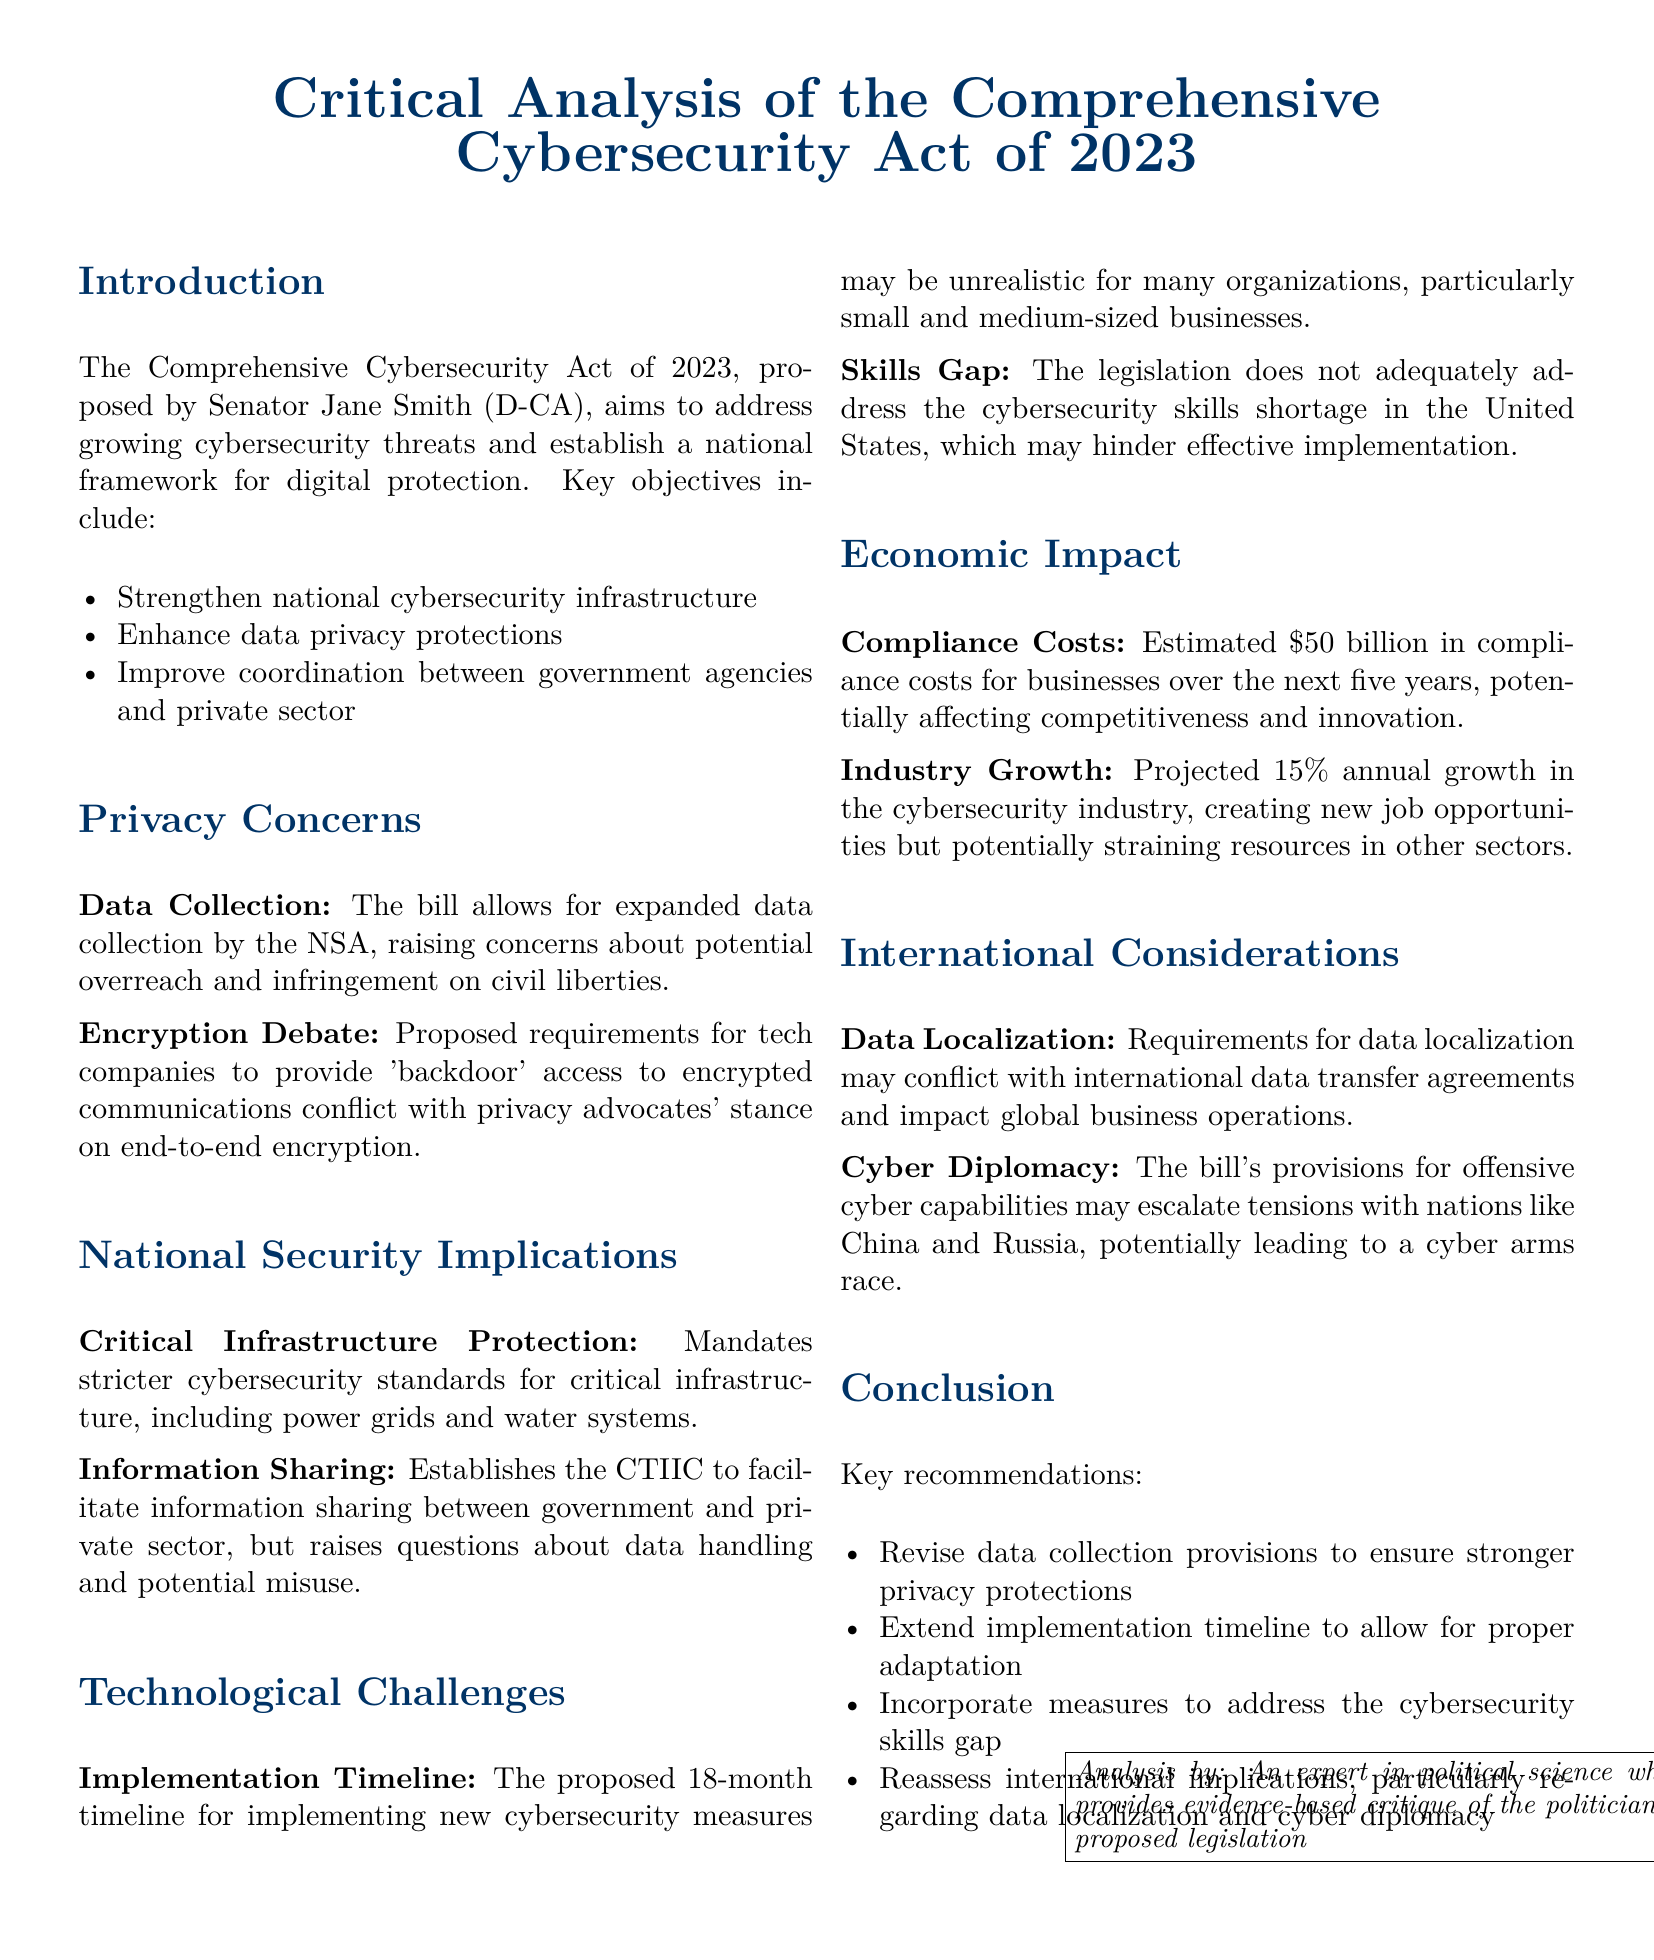What is the title of the proposed legislation? The title is presented at the beginning of the document, highlighting its focus on cybersecurity.
Answer: Comprehensive Cybersecurity Act of 2023 Who proposed the Comprehensive Cybersecurity Act? The document identifies the sponsor of the legislation.
Answer: Senator Jane Smith (D-CA) What is the estimated compliance cost for businesses over five years? This figure is provided in the Economic Impact section of the document.
Answer: $50 billion How long is the proposed implementation timeline for new cybersecurity measures? The document specifies the timeline mentioned in the Technological Challenges section.
Answer: 18 months What percentage is projected for annual growth in the cybersecurity industry? The projected growth rate is included in the Economic Impact section.
Answer: 15% What does the bill require regarding data collection? The Privacy Concerns section addresses the bill's stance on data collection practices.
Answer: Expanded data collection by the NSA What capability does the bill provisions suggest related to cyber operations? The International Considerations section discusses aspects concerning offensive cyber capabilities.
Answer: Offensive cyber capabilities What issue does the legislation not adequately address according to the document? The Technological Challenges section highlights a specific workforce problem.
Answer: Cybersecurity skills shortage What recommendation involves the implementation timeline? The conclusion section presents suggestions for amending certain provisions.
Answer: Extend implementation timeline to allow for proper adaptation 